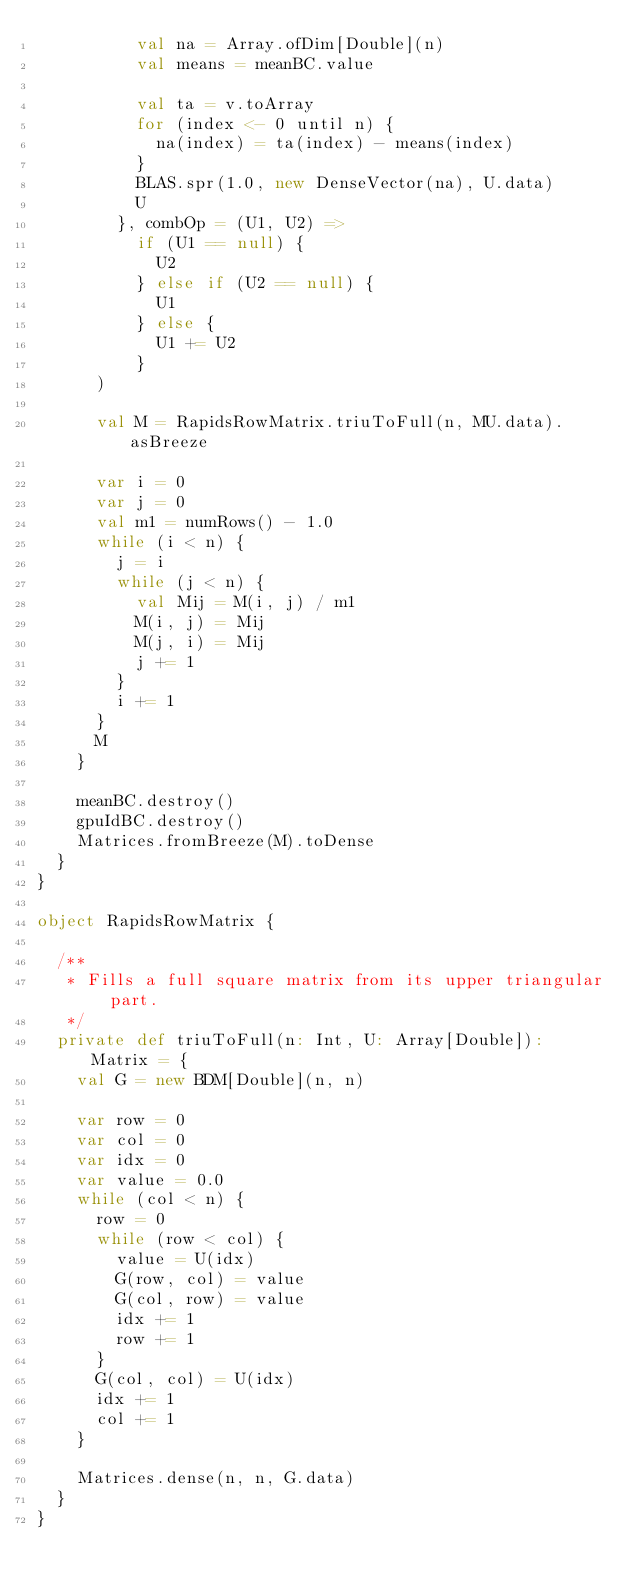Convert code to text. <code><loc_0><loc_0><loc_500><loc_500><_Scala_>          val na = Array.ofDim[Double](n)
          val means = meanBC.value

          val ta = v.toArray
          for (index <- 0 until n) {
            na(index) = ta(index) - means(index)
          }
          BLAS.spr(1.0, new DenseVector(na), U.data)
          U
        }, combOp = (U1, U2) =>
          if (U1 == null) {
            U2
          } else if (U2 == null) {
            U1
          } else {
            U1 += U2
          }
      )

      val M = RapidsRowMatrix.triuToFull(n, MU.data).asBreeze

      var i = 0
      var j = 0
      val m1 = numRows() - 1.0
      while (i < n) {
        j = i
        while (j < n) {
          val Mij = M(i, j) / m1
          M(i, j) = Mij
          M(j, i) = Mij
          j += 1
        }
        i += 1
      }
      M
    }

    meanBC.destroy()
    gpuIdBC.destroy()
    Matrices.fromBreeze(M).toDense
  }
}

object RapidsRowMatrix {

  /**
   * Fills a full square matrix from its upper triangular part.
   */
  private def triuToFull(n: Int, U: Array[Double]): Matrix = {
    val G = new BDM[Double](n, n)

    var row = 0
    var col = 0
    var idx = 0
    var value = 0.0
    while (col < n) {
      row = 0
      while (row < col) {
        value = U(idx)
        G(row, col) = value
        G(col, row) = value
        idx += 1
        row += 1
      }
      G(col, col) = U(idx)
      idx += 1
      col += 1
    }

    Matrices.dense(n, n, G.data)
  }
}
</code> 